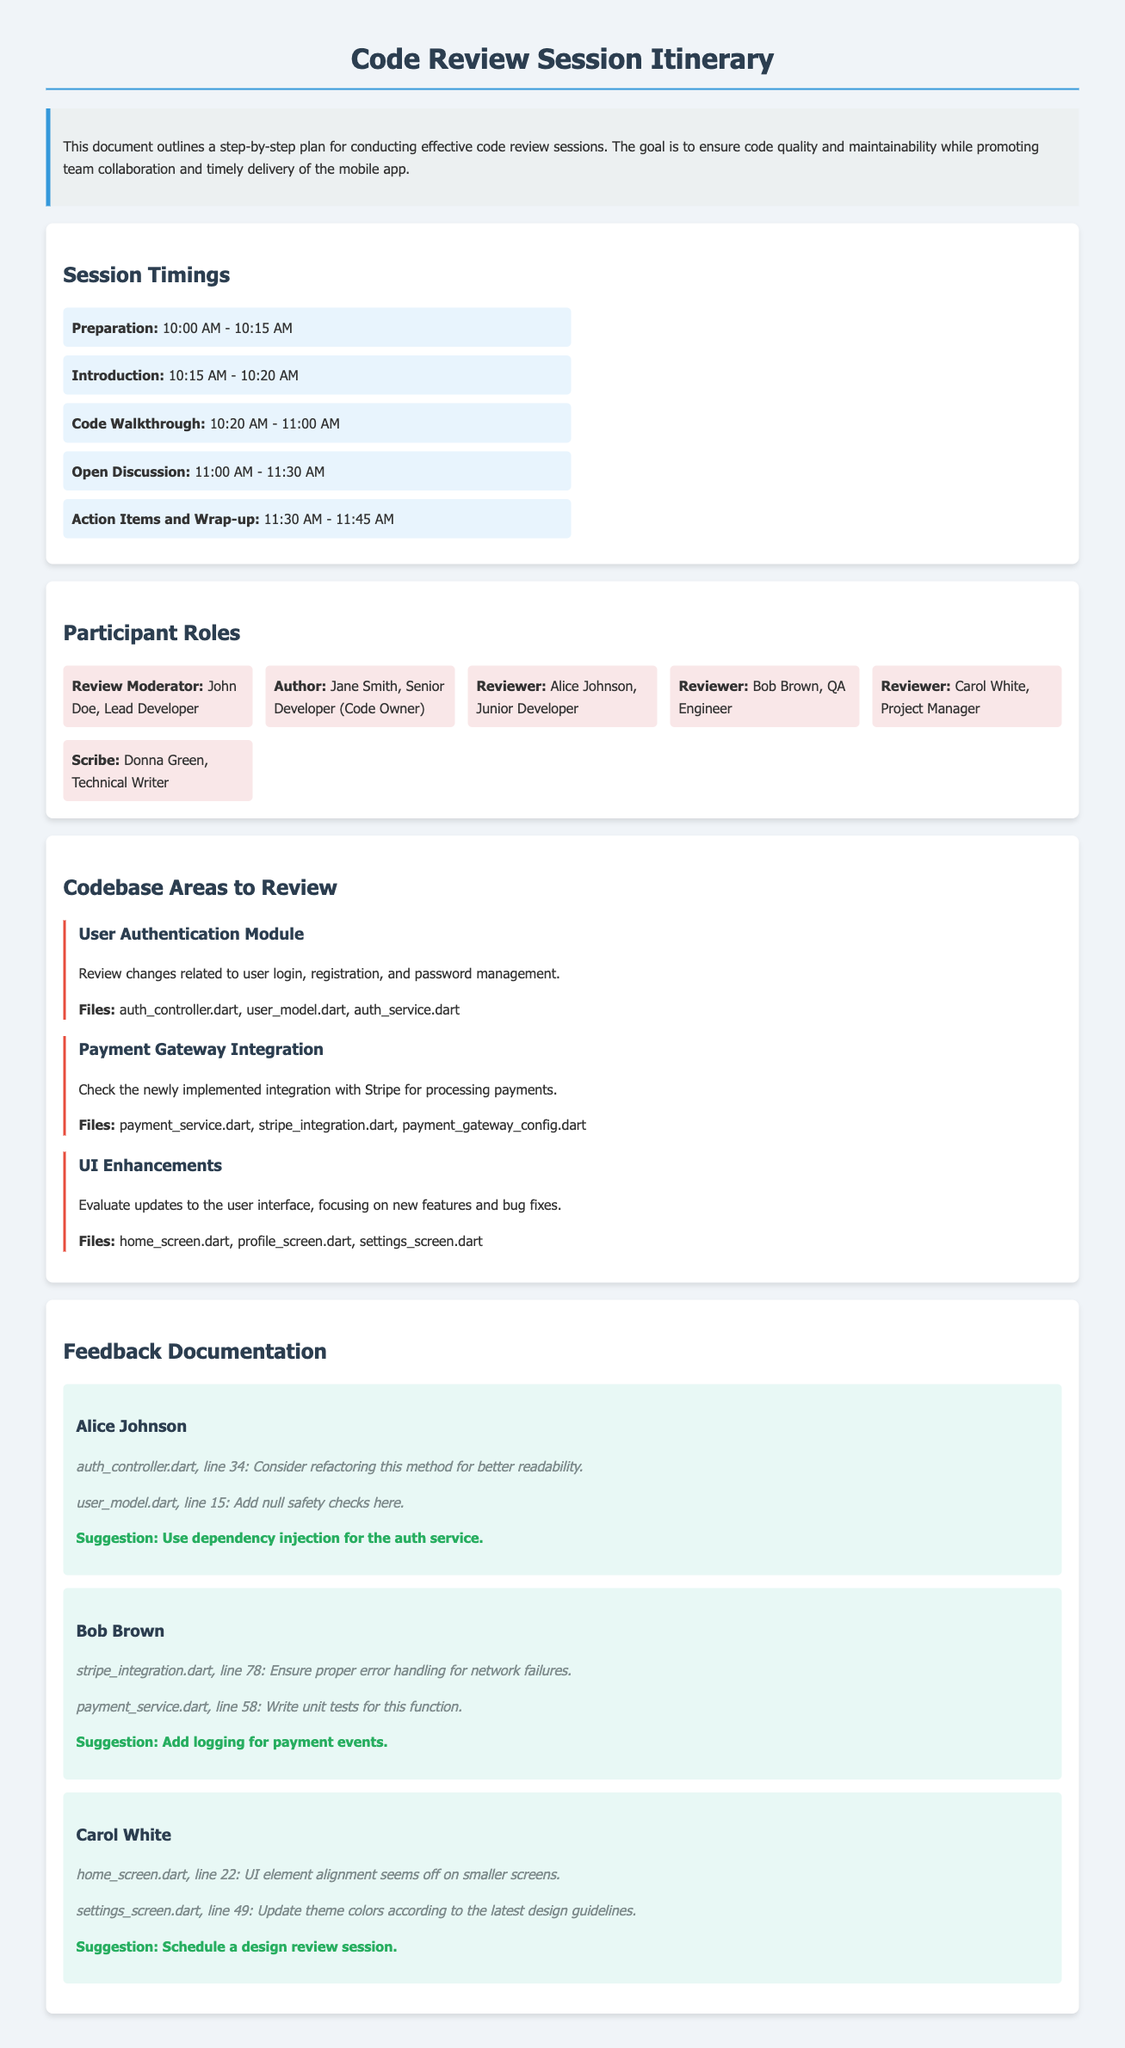What time does the code walkthrough start? The code walkthrough starts at 10:20 AM according to the session timings section.
Answer: 10:20 AM Who is the review moderator? The review moderator is identified in the participant roles section as John Doe.
Answer: John Doe How many reviewers are there in total? The document lists four reviewers in the participant roles section.
Answer: Four What is one of the action items suggested by Alice Johnson? Alice Johnson suggests using dependency injection for the auth service in her feedback documentation.
Answer: Use dependency injection for the auth service Which module is focused on user login and password management? The user authentication module is described as dealing with user login, registration, and password management in the codebase areas to review section.
Answer: User Authentication Module What is the end time of the open discussion? The open discussion ends at 11:30 AM according to the session timings.
Answer: 11:30 AM What file should be reviewed for error handling in the payment integration? The file stripe_integration.dart is mentioned for reviewing error handling in payments in the feedback documentation.
Answer: stripe_integration.dart Who is responsible for taking notes during the session? The scribe is responsible for taking notes, which is Donna Green as per the participant roles section.
Answer: Donna Green What is an identified issue in the home screen file? Carol White mentioned that the UI element alignment seems off on smaller screens in her feedback documentation.
Answer: UI element alignment seems off on smaller screens 